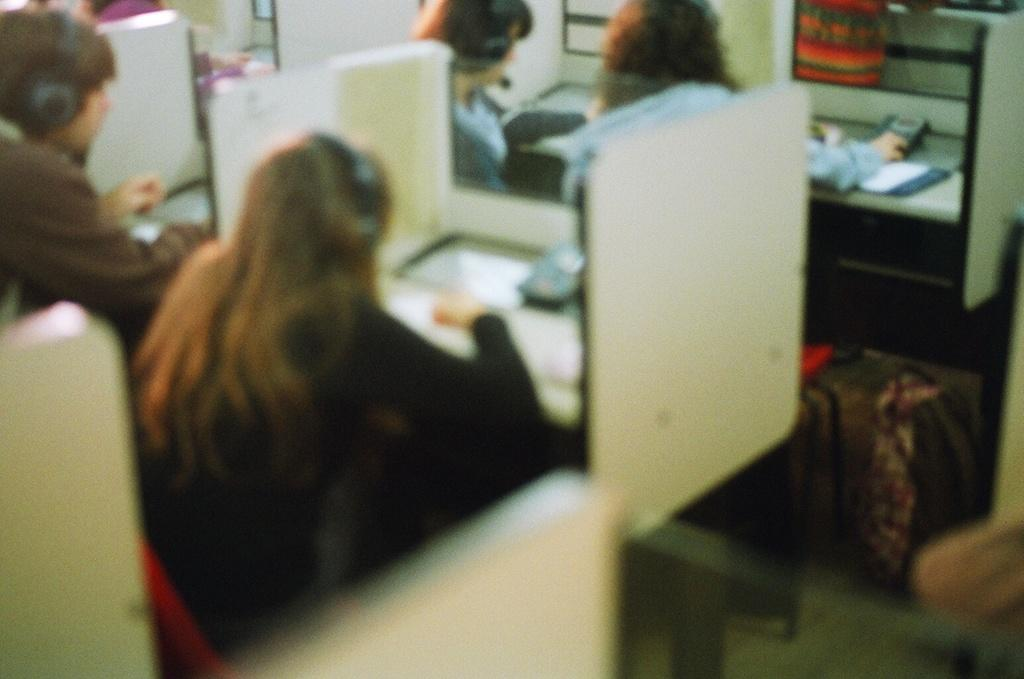What type of furniture is visible in the image? There are desks in the image. What can be found on the desks? Telephones with buttons are present on the desks. What are the people near the desks doing? There are people sitting near the desks. What can be seen on the people's heads? The people are wearing headsets. What type of garden can be seen in the image? There is no garden present in the image. What caption is written on the desks in the image? There is no caption visible on the desks in the image. 